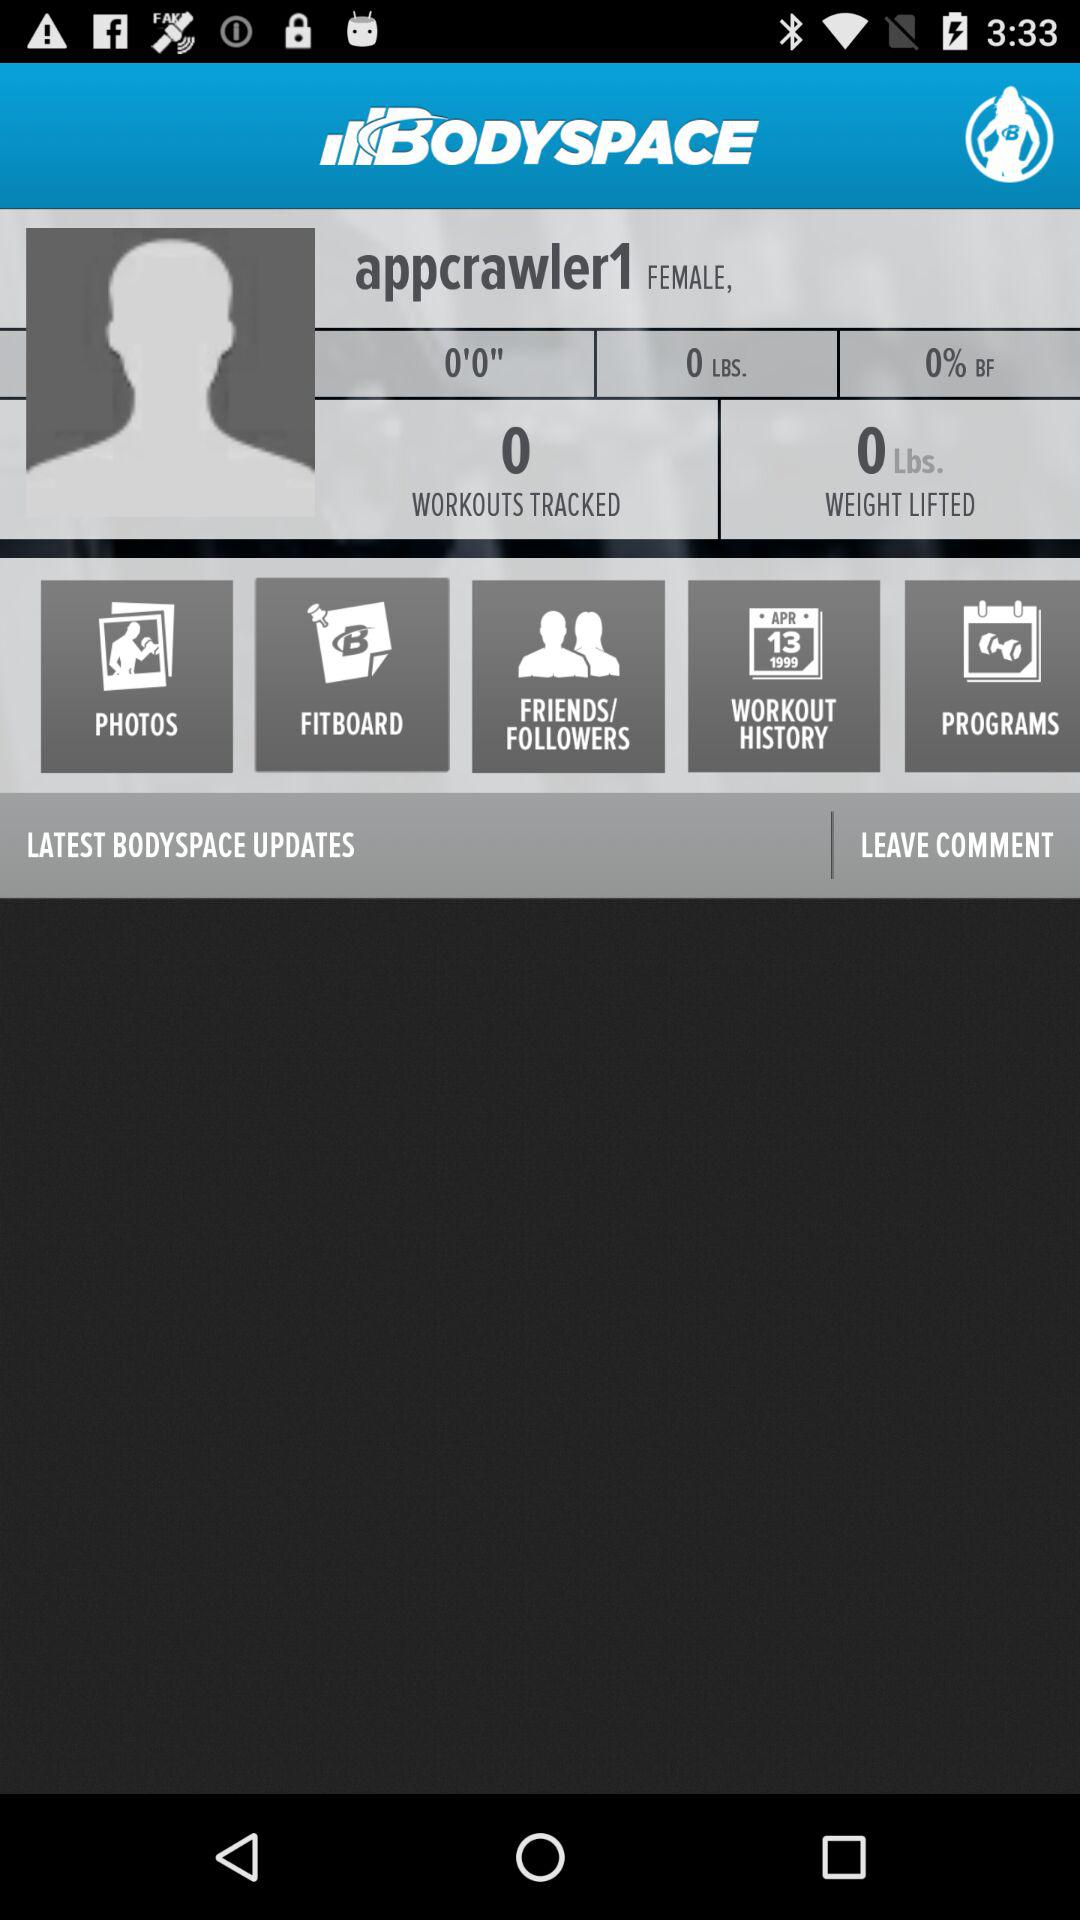What is the gender of the user? The gender of the user is female. 